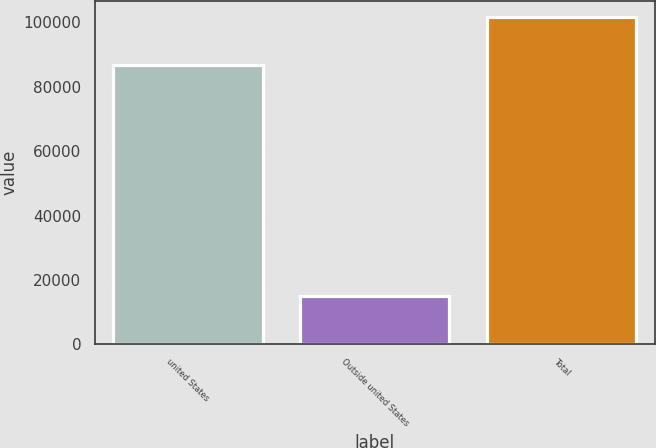Convert chart to OTSL. <chart><loc_0><loc_0><loc_500><loc_500><bar_chart><fcel>united States<fcel>Outside united States<fcel>Total<nl><fcel>86609<fcel>15033<fcel>101642<nl></chart> 